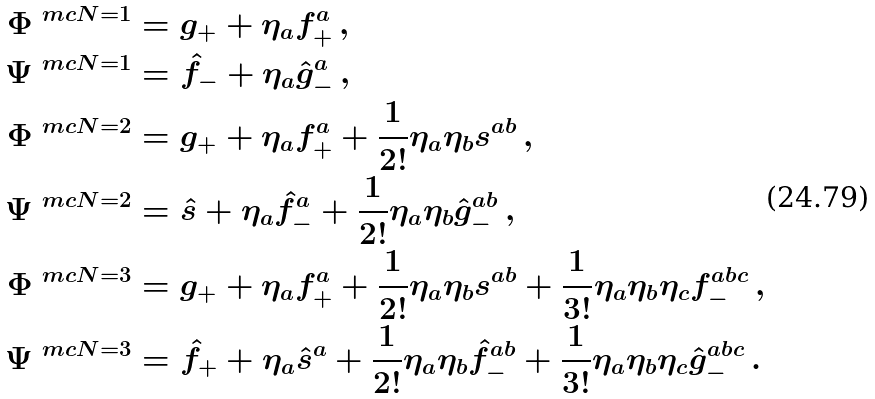Convert formula to latex. <formula><loc_0><loc_0><loc_500><loc_500>\Phi ^ { \ m c N = 1 } & = g _ { + } + \eta _ { a } f ^ { a } _ { + } \, , \\ \Psi ^ { \ m c N = 1 } & = \hat { f } _ { - } + \eta _ { a } \hat { g } _ { - } ^ { a } \, , \\ \Phi ^ { \ m c N = 2 } & = g _ { + } + \eta _ { a } f ^ { a } _ { + } + \frac { 1 } { 2 ! } \eta _ { a } \eta _ { b } s ^ { a b } \, , \\ \Psi ^ { \ m c N = 2 } & = \hat { s } + \eta _ { a } \hat { f } ^ { a } _ { - } + \frac { 1 } { 2 ! } \eta _ { a } \eta _ { b } \hat { g } ^ { a b } _ { - } \, , \\ \Phi ^ { \ m c N = 3 } & = g _ { + } + \eta _ { a } f ^ { a } _ { + } + \frac { 1 } { 2 ! } \eta _ { a } \eta _ { b } s ^ { a b } + \frac { 1 } { 3 ! } \eta _ { a } \eta _ { b } \eta _ { c } f ^ { a b c } _ { - } \, , \\ \Psi ^ { \ m c N = 3 } & = \hat { f } _ { + } + \eta _ { a } \hat { s } ^ { a } + \frac { 1 } { 2 ! } \eta _ { a } \eta _ { b } \hat { f } ^ { a b } _ { - } + \frac { 1 } { 3 ! } \eta _ { a } \eta _ { b } \eta _ { c } \hat { g } ^ { a b c } _ { - } \, .</formula> 